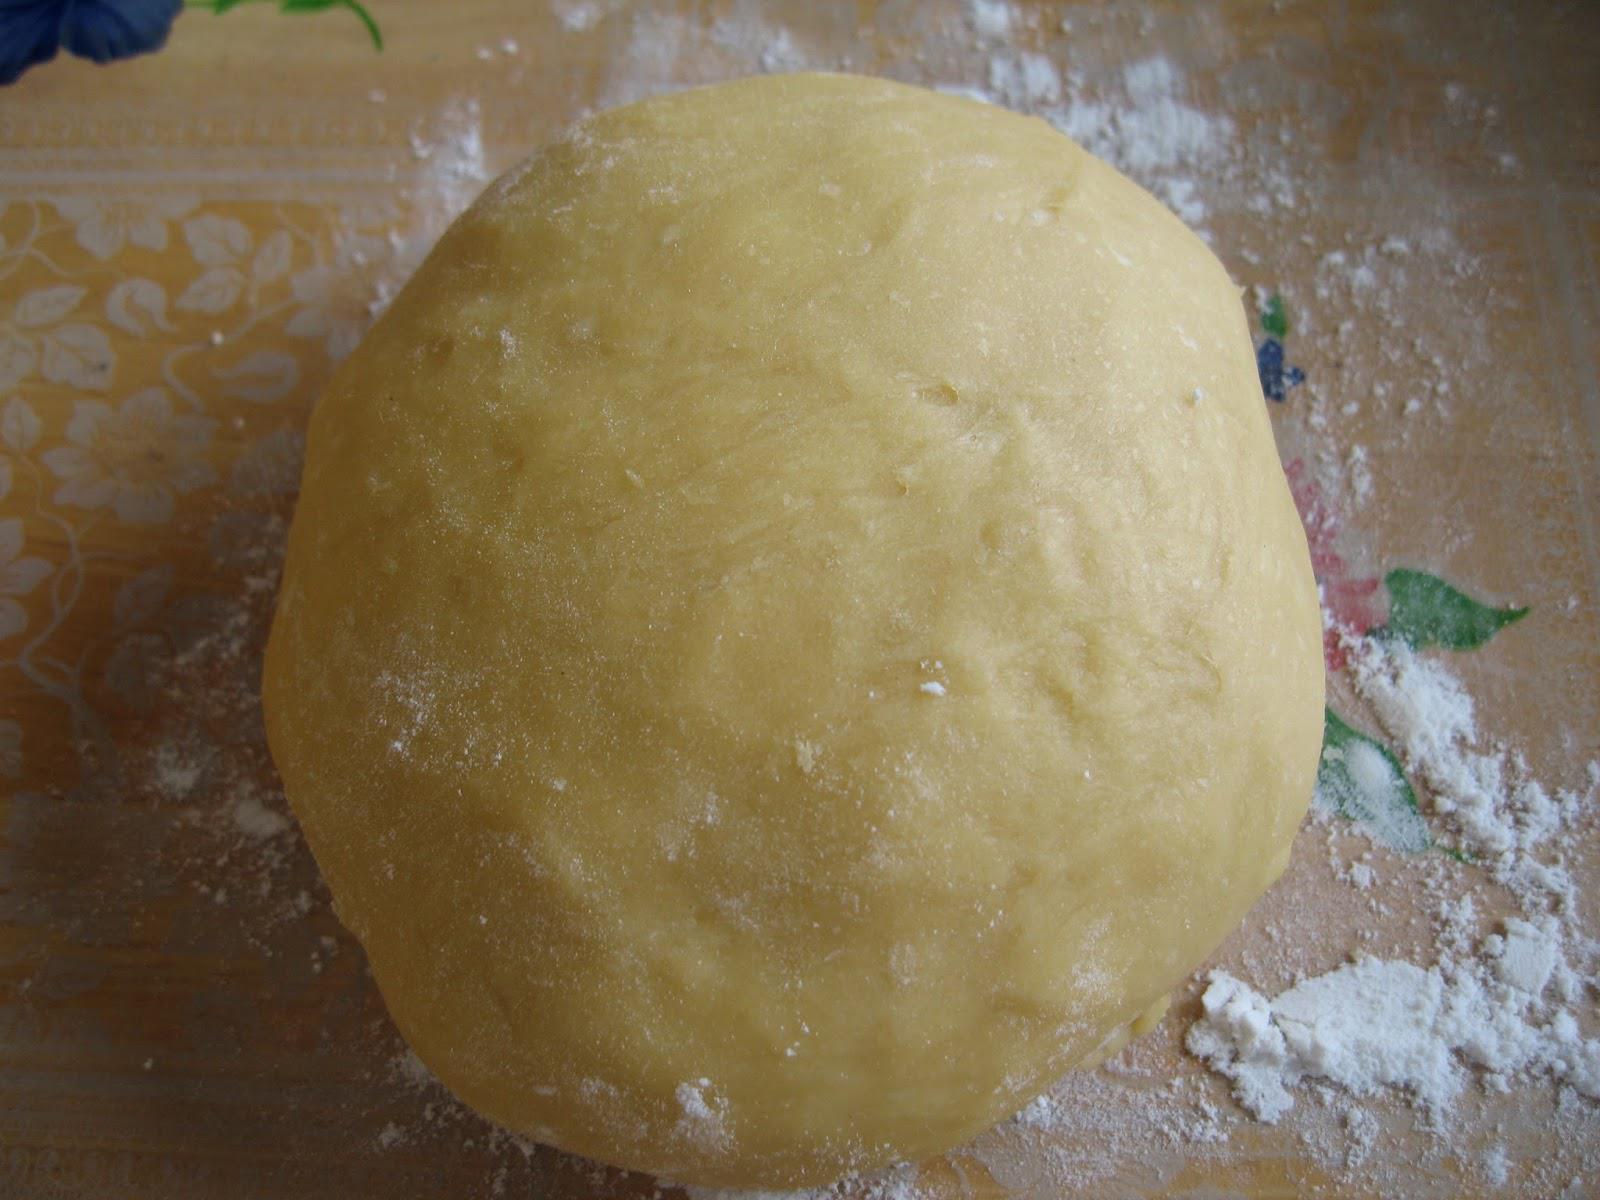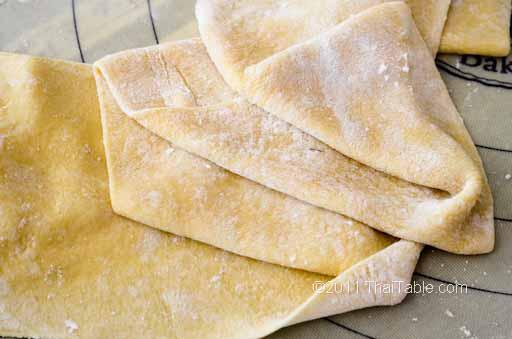The first image is the image on the left, the second image is the image on the right. Given the left and right images, does the statement "The left image shows dough in a roundish shape on a floured board, and the right image shows dough that has been flattened." hold true? Answer yes or no. Yes. The first image is the image on the left, the second image is the image on the right. For the images shown, is this caption "A rolling pin is on a wooden cutting board." true? Answer yes or no. No. 